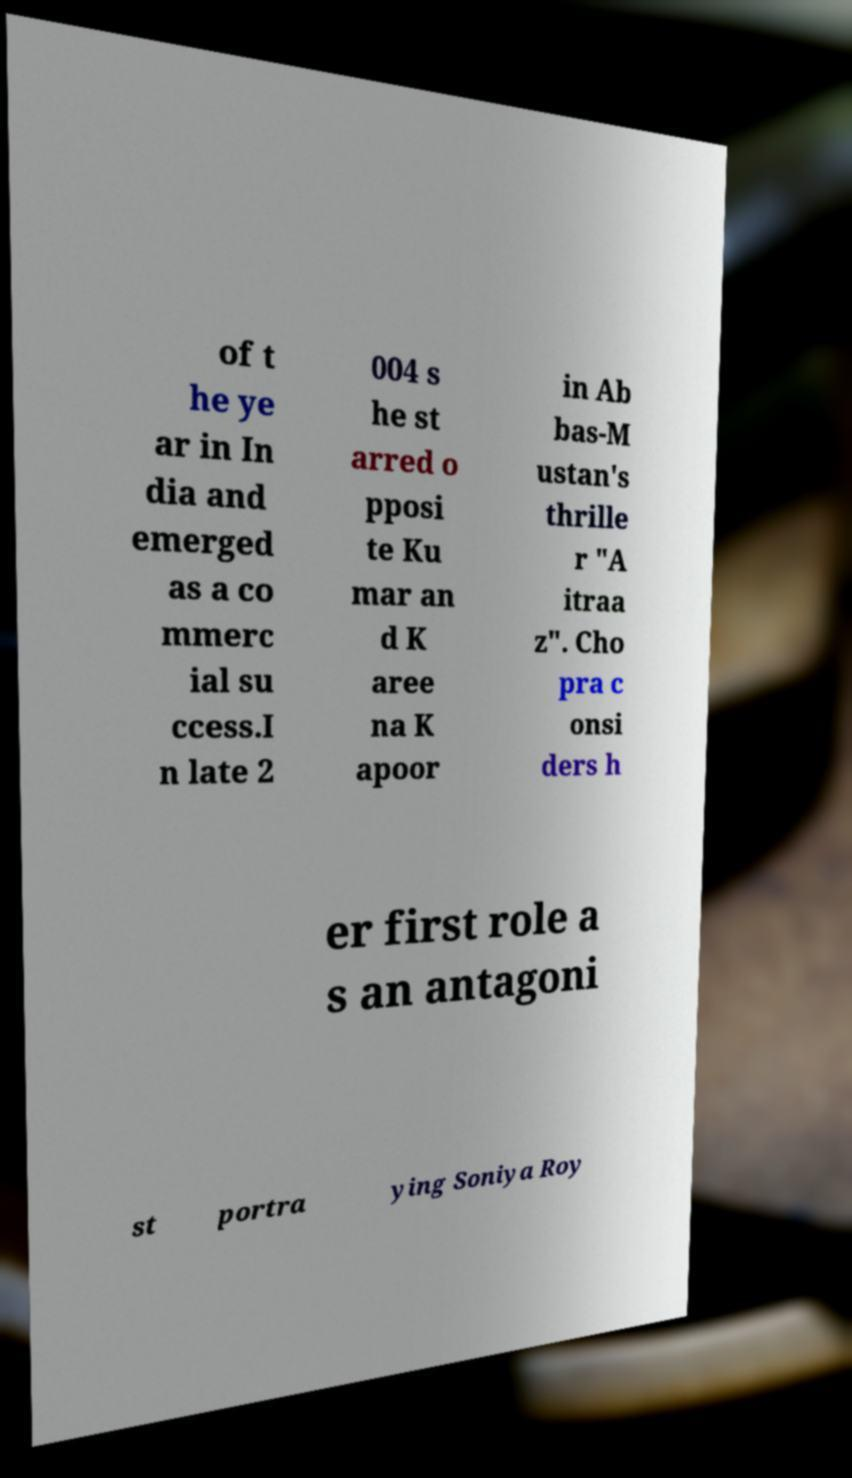Please read and relay the text visible in this image. What does it say? of t he ye ar in In dia and emerged as a co mmerc ial su ccess.I n late 2 004 s he st arred o pposi te Ku mar an d K aree na K apoor in Ab bas-M ustan's thrille r "A itraa z". Cho pra c onsi ders h er first role a s an antagoni st portra ying Soniya Roy 